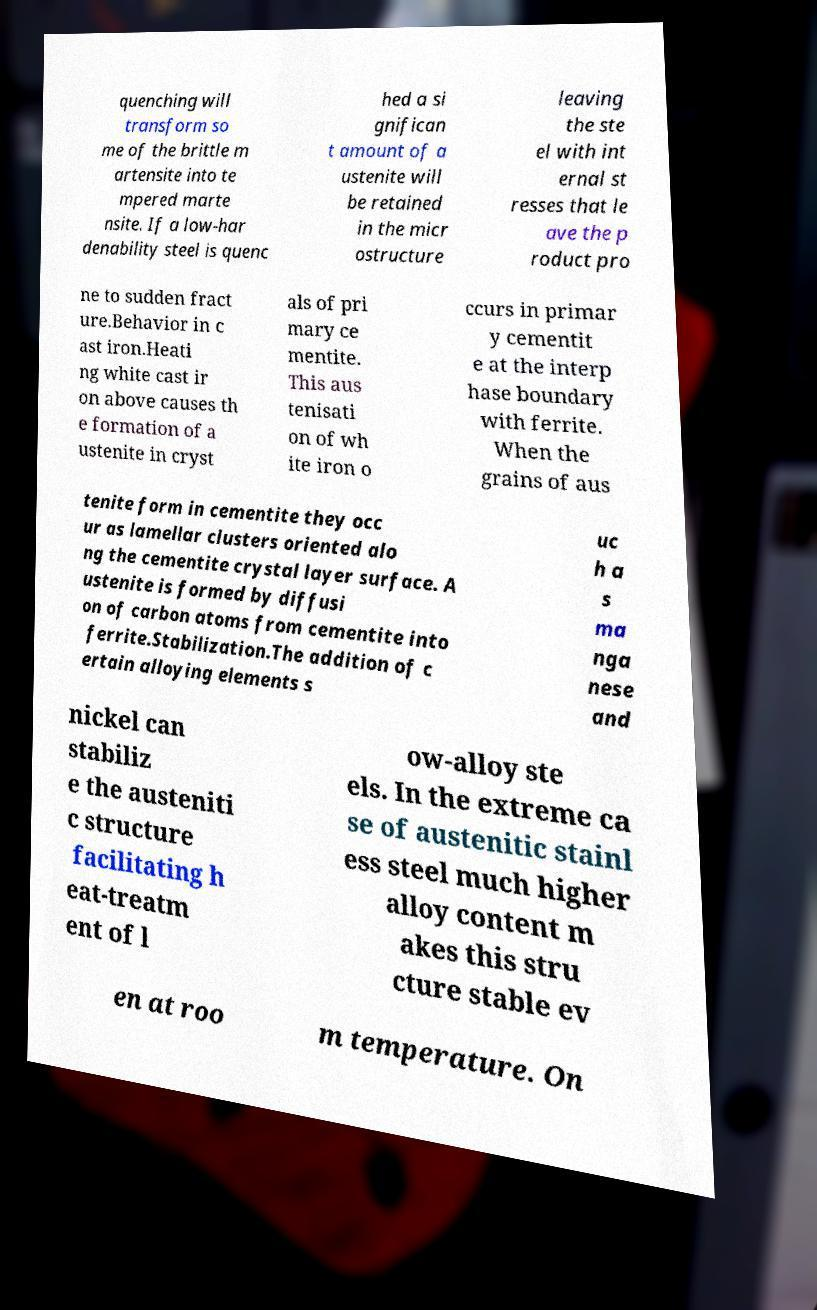What messages or text are displayed in this image? I need them in a readable, typed format. quenching will transform so me of the brittle m artensite into te mpered marte nsite. If a low-har denability steel is quenc hed a si gnifican t amount of a ustenite will be retained in the micr ostructure leaving the ste el with int ernal st resses that le ave the p roduct pro ne to sudden fract ure.Behavior in c ast iron.Heati ng white cast ir on above causes th e formation of a ustenite in cryst als of pri mary ce mentite. This aus tenisati on of wh ite iron o ccurs in primar y cementit e at the interp hase boundary with ferrite. When the grains of aus tenite form in cementite they occ ur as lamellar clusters oriented alo ng the cementite crystal layer surface. A ustenite is formed by diffusi on of carbon atoms from cementite into ferrite.Stabilization.The addition of c ertain alloying elements s uc h a s ma nga nese and nickel can stabiliz e the austeniti c structure facilitating h eat-treatm ent of l ow-alloy ste els. In the extreme ca se of austenitic stainl ess steel much higher alloy content m akes this stru cture stable ev en at roo m temperature. On 